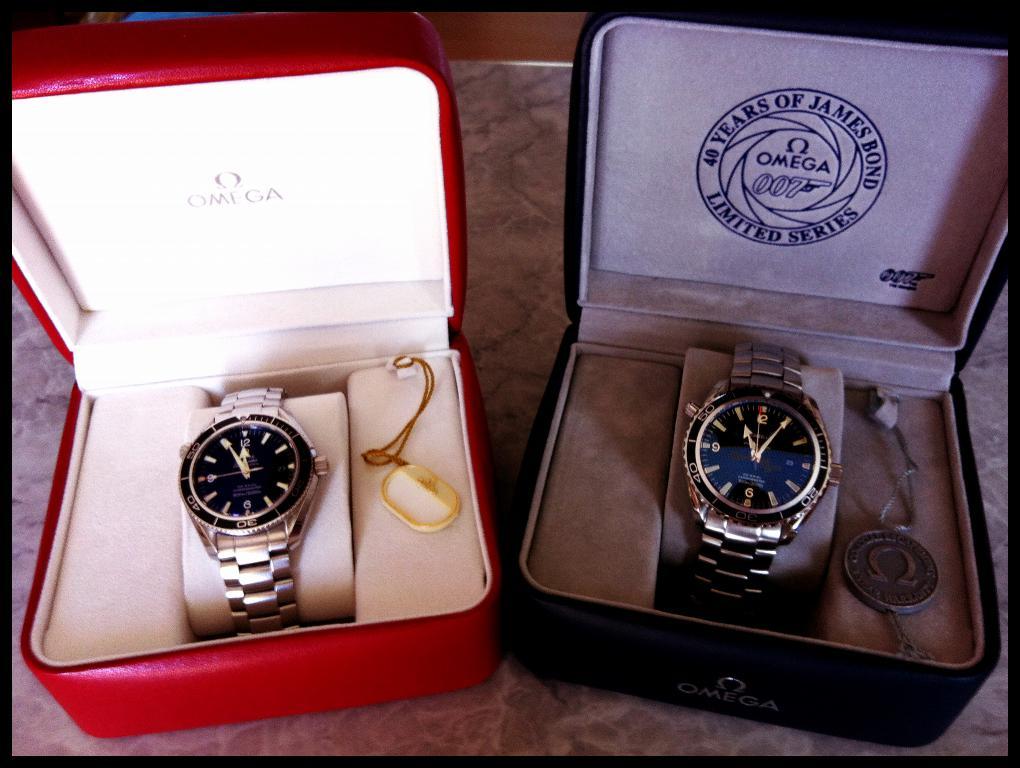What brand are the watches?
Keep it short and to the point. Omega. How many years of james bond?
Your response must be concise. 40. 